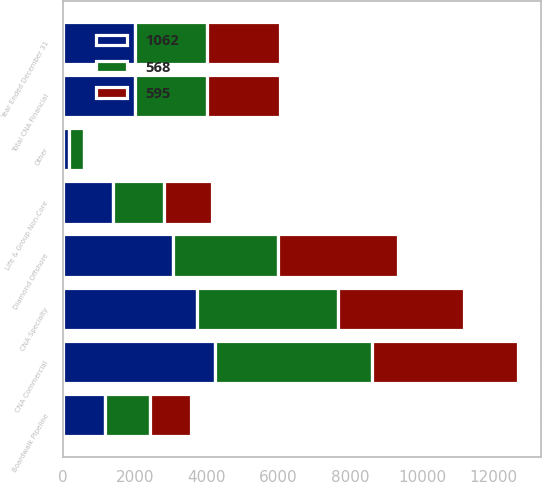Convert chart to OTSL. <chart><loc_0><loc_0><loc_500><loc_500><stacked_bar_chart><ecel><fcel>Year Ended December 31<fcel>CNA Specialty<fcel>CNA Commercial<fcel>Life & Group Non-Core<fcel>Other<fcel>Total CNA Financial<fcel>Diamond Offshore<fcel>Boardwalk Pipeline<nl><fcel>568<fcel>2013<fcel>3915<fcel>4360<fcel>1424<fcel>414<fcel>2012<fcel>2926<fcel>1232<nl><fcel>1062<fcel>2012<fcel>3742<fcel>4238<fcel>1395<fcel>172<fcel>2012<fcel>3072<fcel>1187<nl><fcel>595<fcel>2011<fcel>3512<fcel>4073<fcel>1334<fcel>44<fcel>2012<fcel>3334<fcel>1144<nl></chart> 